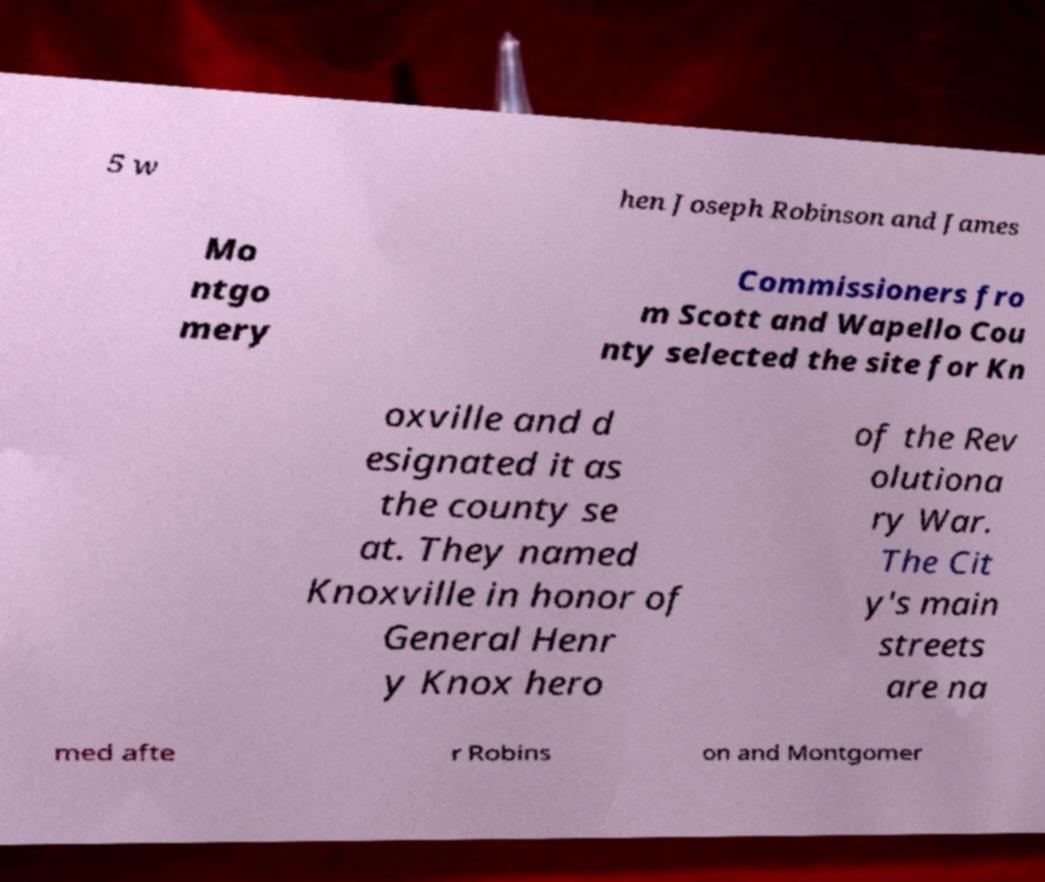I need the written content from this picture converted into text. Can you do that? 5 w hen Joseph Robinson and James Mo ntgo mery Commissioners fro m Scott and Wapello Cou nty selected the site for Kn oxville and d esignated it as the county se at. They named Knoxville in honor of General Henr y Knox hero of the Rev olutiona ry War. The Cit y's main streets are na med afte r Robins on and Montgomer 